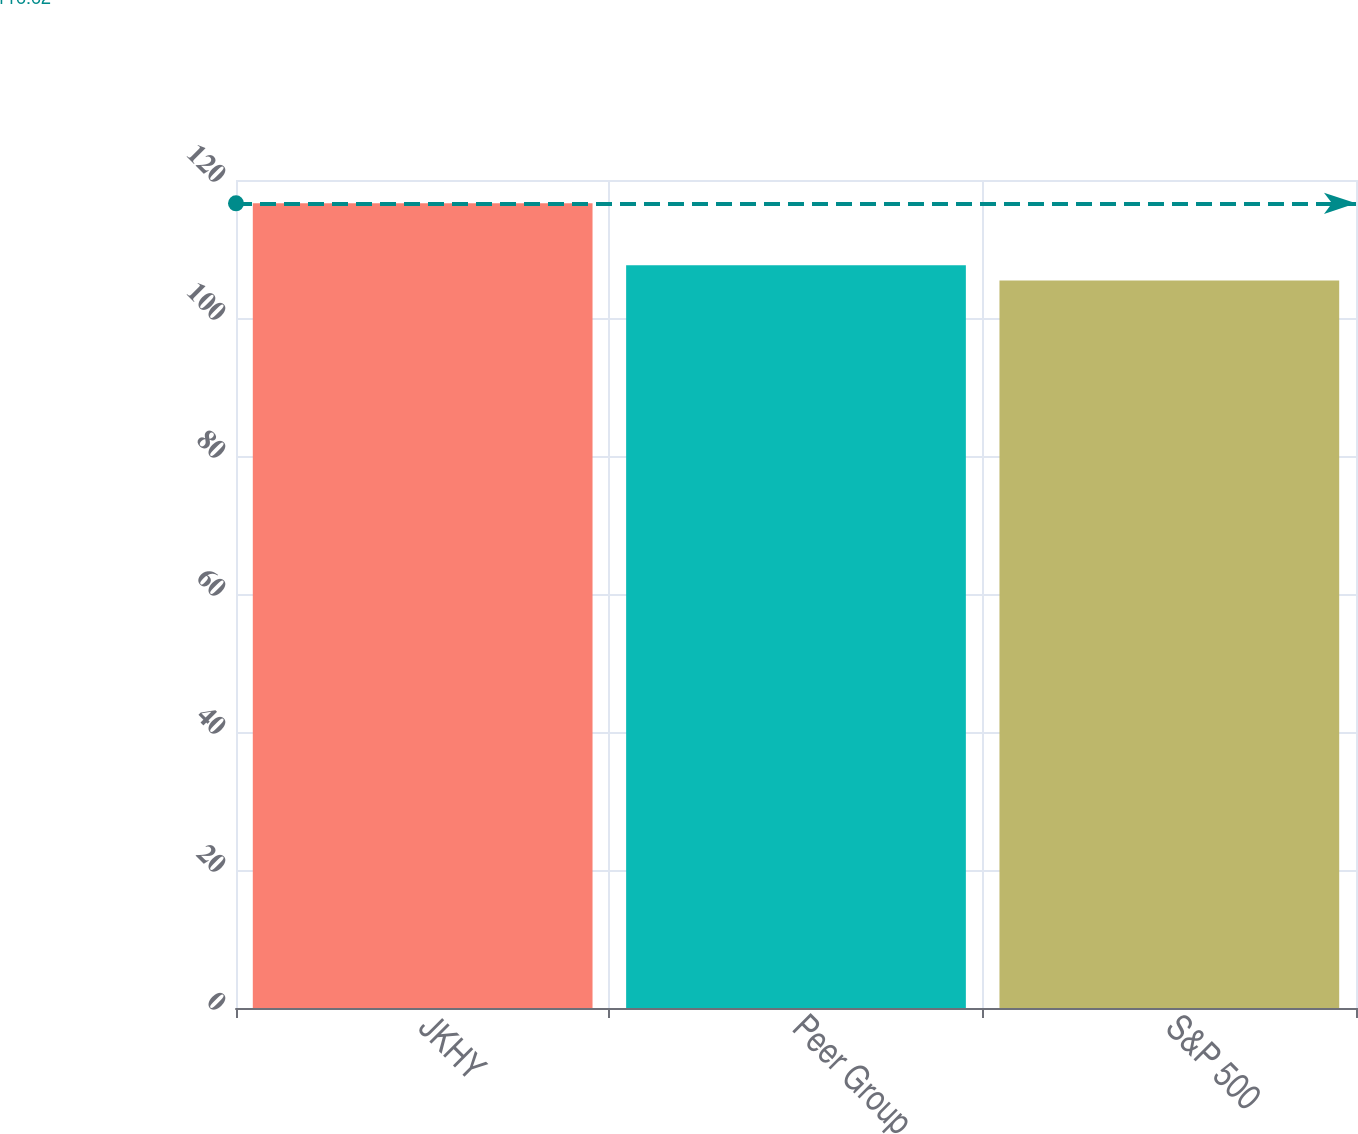<chart> <loc_0><loc_0><loc_500><loc_500><bar_chart><fcel>JKHY<fcel>Peer Group<fcel>S&P 500<nl><fcel>116.62<fcel>107.65<fcel>105.45<nl></chart> 